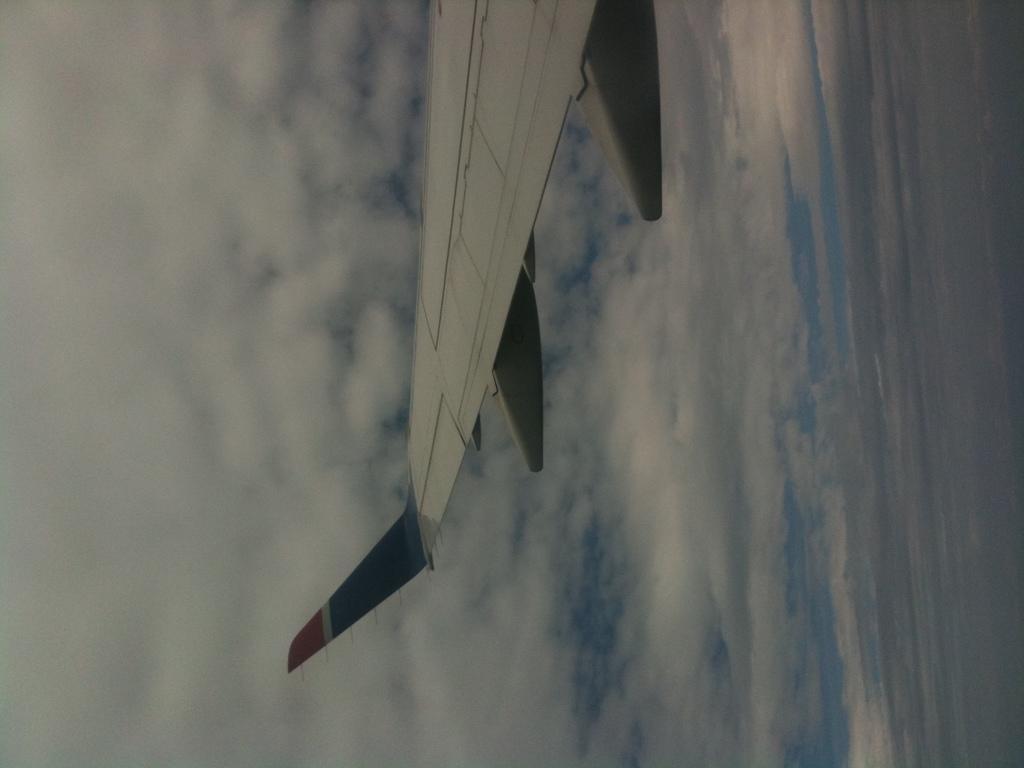Could you give a brief overview of what you see in this image? In this image there is wing part of airplane. There are clouds in the sky. 